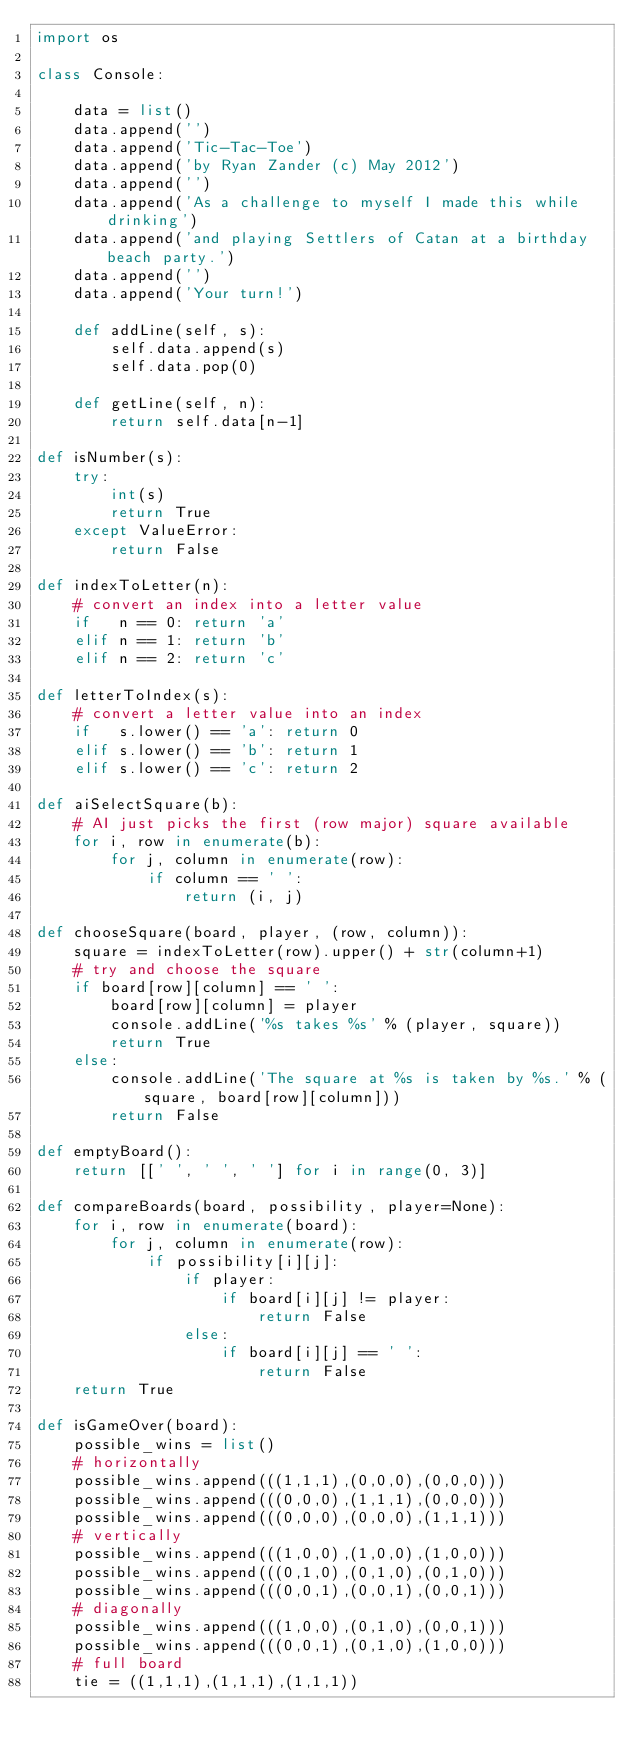<code> <loc_0><loc_0><loc_500><loc_500><_Python_>import os

class Console:

    data = list()
    data.append('')
    data.append('Tic-Tac-Toe')
    data.append('by Ryan Zander (c) May 2012')
    data.append('')
    data.append('As a challenge to myself I made this while drinking')
    data.append('and playing Settlers of Catan at a birthday beach party.')
    data.append('')
    data.append('Your turn!')

    def addLine(self, s):
        self.data.append(s)
        self.data.pop(0)

    def getLine(self, n):
        return self.data[n-1]

def isNumber(s):
    try:
        int(s)
        return True
    except ValueError:
        return False

def indexToLetter(n):
    # convert an index into a letter value
    if   n == 0: return 'a'
    elif n == 1: return 'b'
    elif n == 2: return 'c'

def letterToIndex(s):
    # convert a letter value into an index
    if   s.lower() == 'a': return 0
    elif s.lower() == 'b': return 1
    elif s.lower() == 'c': return 2

def aiSelectSquare(b):
    # AI just picks the first (row major) square available
    for i, row in enumerate(b):
        for j, column in enumerate(row):
            if column == ' ':
                return (i, j)

def chooseSquare(board, player, (row, column)):
    square = indexToLetter(row).upper() + str(column+1)
    # try and choose the square
    if board[row][column] == ' ':
        board[row][column] = player
        console.addLine('%s takes %s' % (player, square))
        return True
    else:
        console.addLine('The square at %s is taken by %s.' % (square, board[row][column]))
        return False

def emptyBoard():
    return [[' ', ' ', ' '] for i in range(0, 3)]

def compareBoards(board, possibility, player=None):
    for i, row in enumerate(board):
        for j, column in enumerate(row):
            if possibility[i][j]:
                if player:
                    if board[i][j] != player:
                        return False
                else:
                    if board[i][j] == ' ':
                        return False
    return True

def isGameOver(board):
    possible_wins = list()
    # horizontally
    possible_wins.append(((1,1,1),(0,0,0),(0,0,0)))
    possible_wins.append(((0,0,0),(1,1,1),(0,0,0)))
    possible_wins.append(((0,0,0),(0,0,0),(1,1,1)))
    # vertically
    possible_wins.append(((1,0,0),(1,0,0),(1,0,0)))
    possible_wins.append(((0,1,0),(0,1,0),(0,1,0)))
    possible_wins.append(((0,0,1),(0,0,1),(0,0,1)))
    # diagonally
    possible_wins.append(((1,0,0),(0,1,0),(0,0,1)))
    possible_wins.append(((0,0,1),(0,1,0),(1,0,0)))
    # full board
    tie = ((1,1,1),(1,1,1),(1,1,1))
</code> 